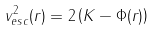Convert formula to latex. <formula><loc_0><loc_0><loc_500><loc_500>v ^ { 2 } _ { e s c } ( r ) = 2 \left ( K - \Phi ( r ) \right )</formula> 